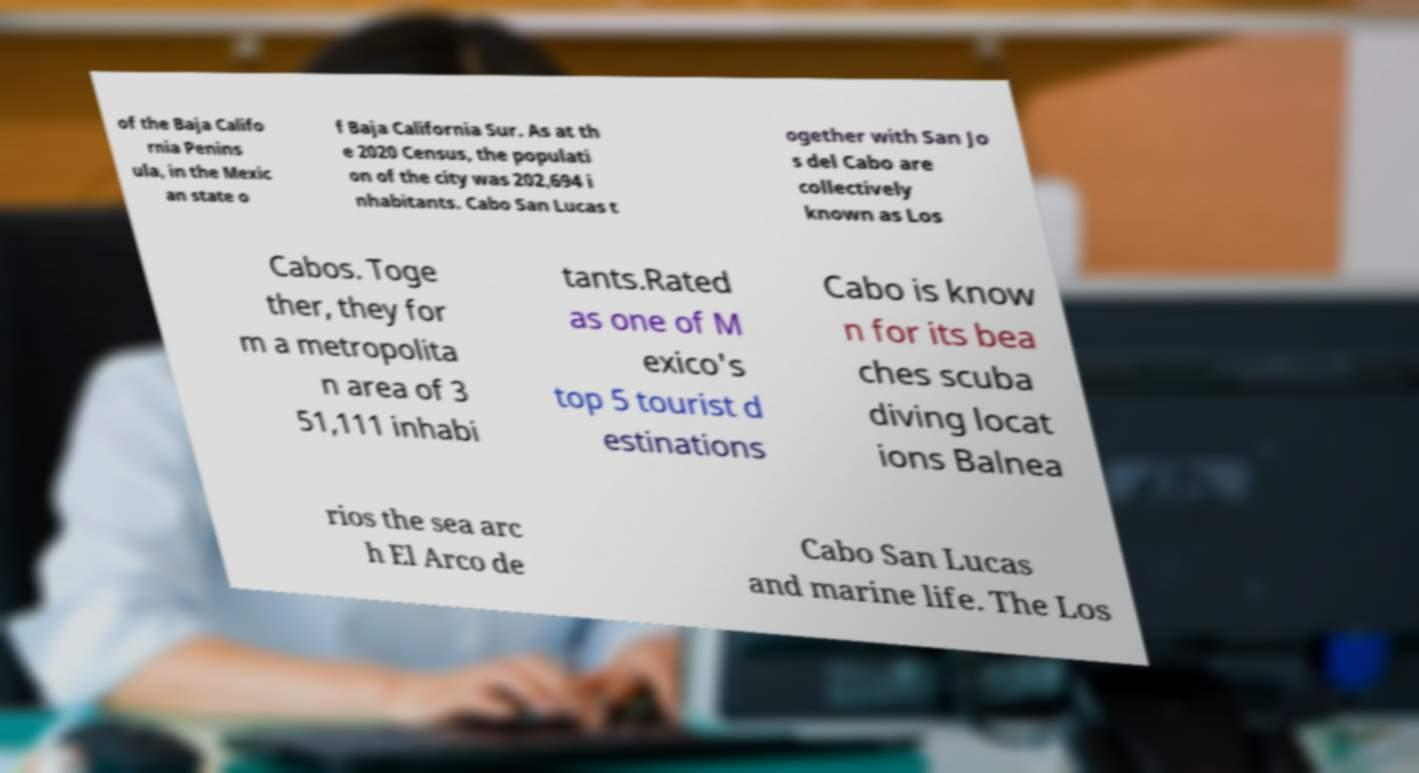For documentation purposes, I need the text within this image transcribed. Could you provide that? of the Baja Califo rnia Penins ula, in the Mexic an state o f Baja California Sur. As at th e 2020 Census, the populati on of the city was 202,694 i nhabitants. Cabo San Lucas t ogether with San Jo s del Cabo are collectively known as Los Cabos. Toge ther, they for m a metropolita n area of 3 51,111 inhabi tants.Rated as one of M exico's top 5 tourist d estinations Cabo is know n for its bea ches scuba diving locat ions Balnea rios the sea arc h El Arco de Cabo San Lucas and marine life. The Los 